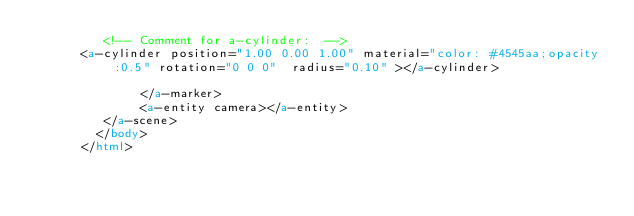Convert code to text. <code><loc_0><loc_0><loc_500><loc_500><_HTML_>         <!-- Comment for a-cylinder:  -->
      <a-cylinder position="1.00 0.00 1.00" material="color: #4545aa;opacity:0.5" rotation="0 0 0"  radius="0.10" ></a-cylinder>

              </a-marker>
              <a-entity camera></a-entity>
         </a-scene>
        </body>
      </html>
</code> 